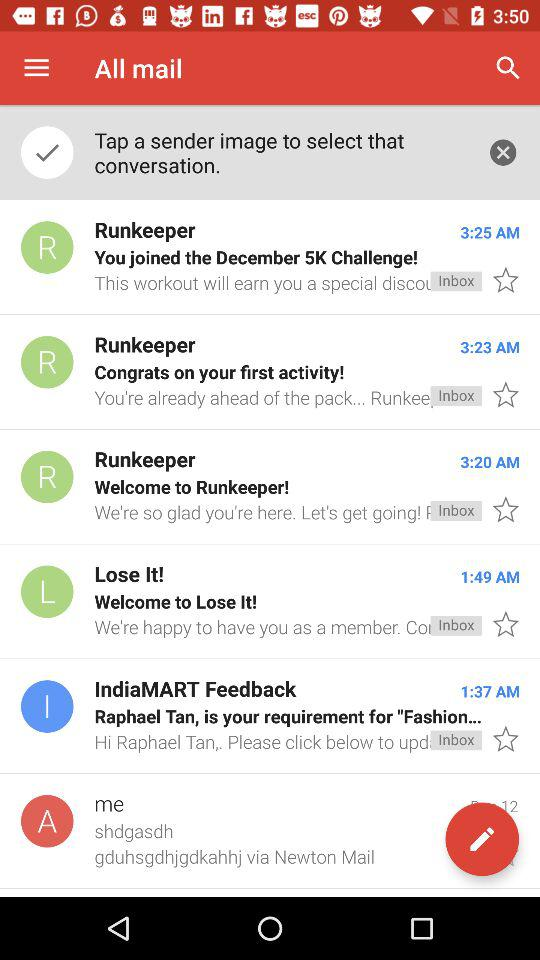How many items are in the inbox?
Answer the question using a single word or phrase. 6 